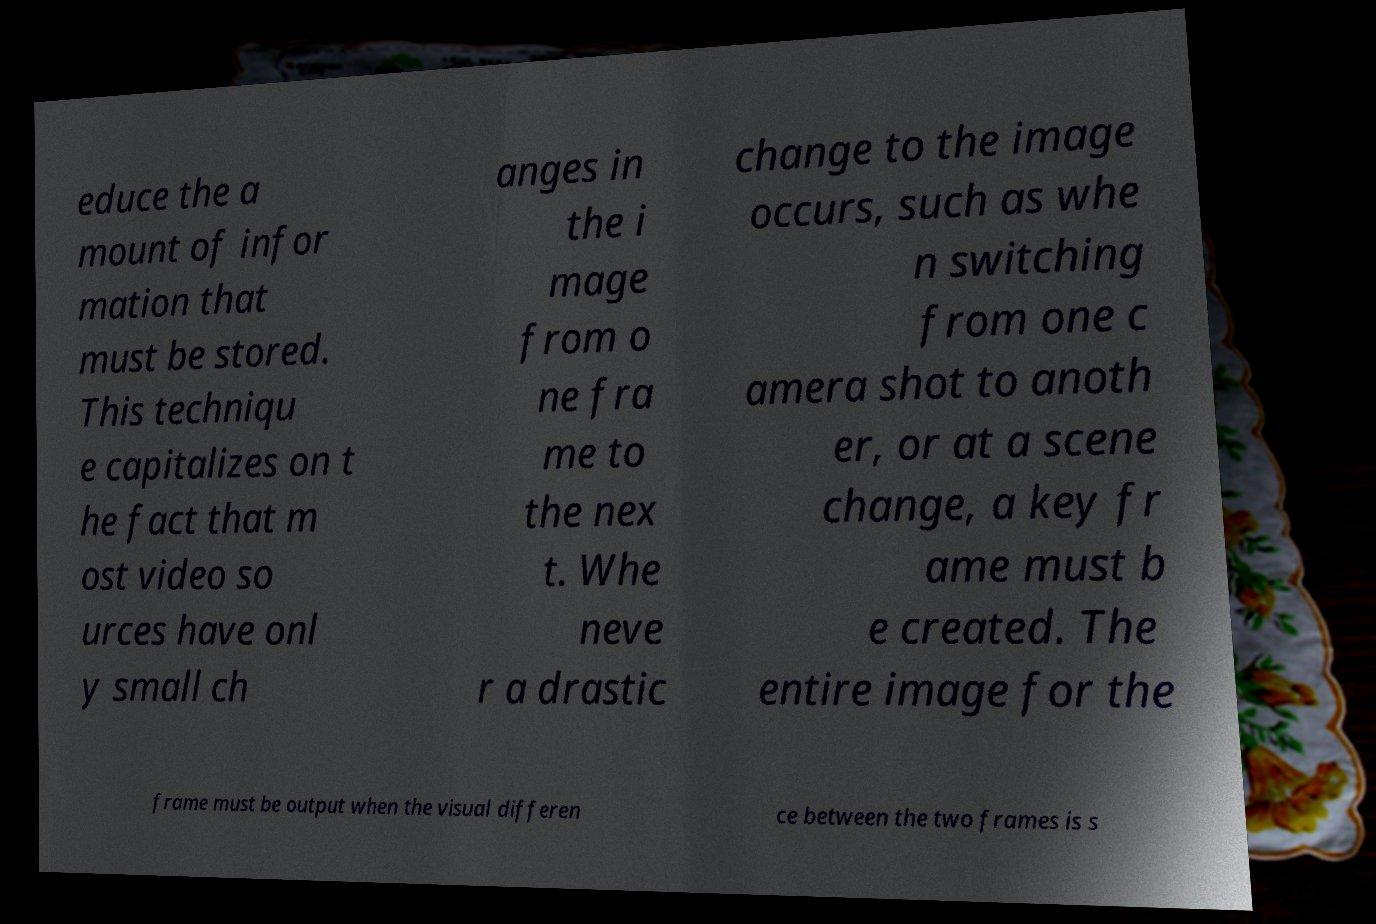For documentation purposes, I need the text within this image transcribed. Could you provide that? educe the a mount of infor mation that must be stored. This techniqu e capitalizes on t he fact that m ost video so urces have onl y small ch anges in the i mage from o ne fra me to the nex t. Whe neve r a drastic change to the image occurs, such as whe n switching from one c amera shot to anoth er, or at a scene change, a key fr ame must b e created. The entire image for the frame must be output when the visual differen ce between the two frames is s 